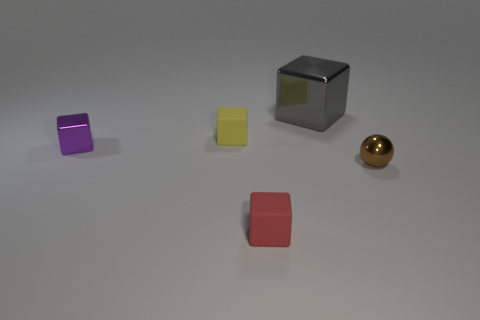What number of things are either tiny things in front of the brown ball or large cyan rubber cylinders?
Give a very brief answer. 1. There is a metal thing that is the same size as the metallic sphere; what is its color?
Your response must be concise. Purple. Are there more objects that are right of the purple block than small yellow things?
Keep it short and to the point. Yes. There is a small cube that is both behind the tiny red rubber block and in front of the yellow matte cube; what material is it?
Your answer should be very brief. Metal. How many other objects are the same size as the yellow thing?
Your answer should be very brief. 3. There is a metal cube that is to the right of the tiny yellow cube that is on the left side of the small brown shiny thing; is there a red thing behind it?
Your answer should be compact. No. Do the small cube to the left of the small yellow object and the large gray cube have the same material?
Provide a succinct answer. Yes. What color is the other small rubber object that is the same shape as the yellow matte object?
Provide a short and direct response. Red. Is there anything else that has the same shape as the purple object?
Your answer should be compact. Yes. Are there the same number of big gray metal things in front of the red object and tiny yellow things?
Provide a short and direct response. No. 